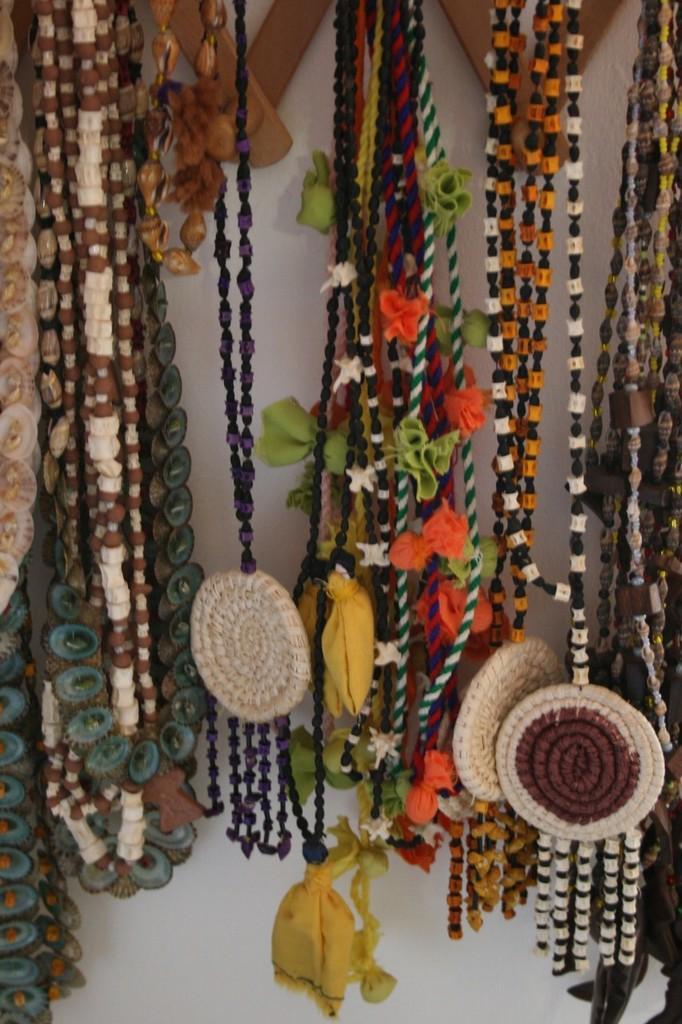Can you describe this image briefly? In this picture we can see decorative items and there is a white background. 